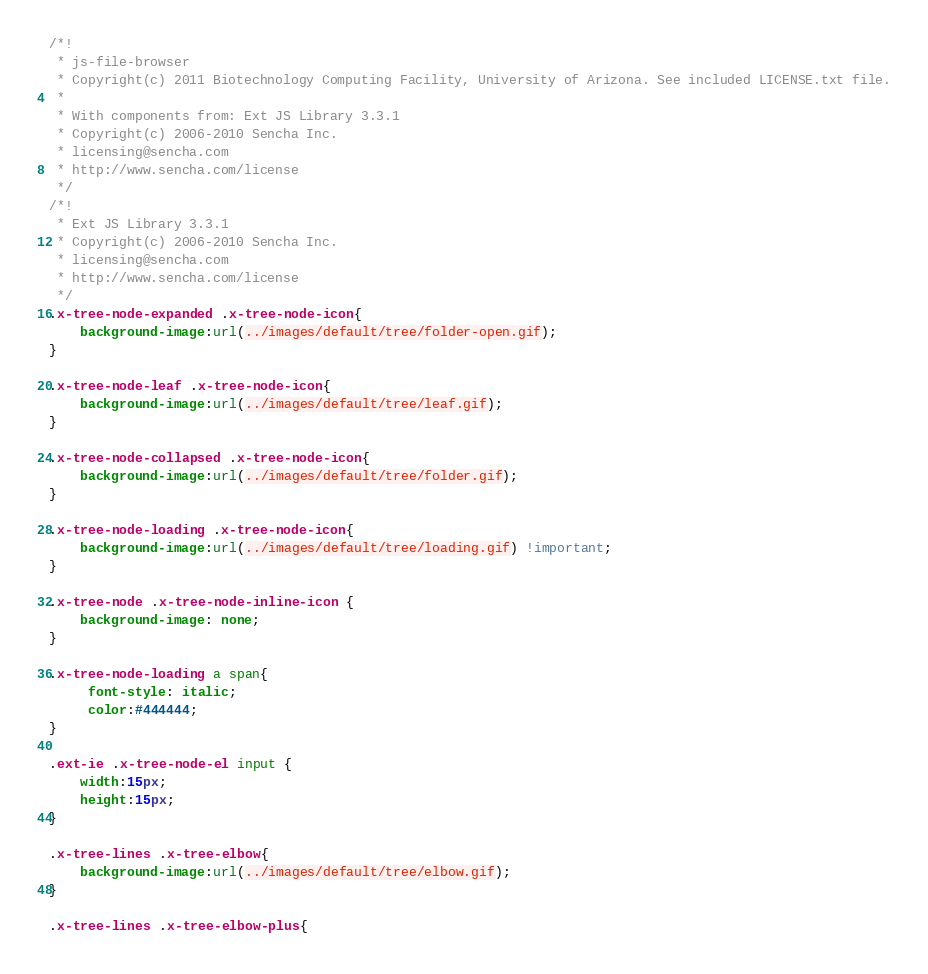Convert code to text. <code><loc_0><loc_0><loc_500><loc_500><_CSS_>/*!
 * js-file-browser
 * Copyright(c) 2011 Biotechnology Computing Facility, University of Arizona. See included LICENSE.txt file.
 * 
 * With components from: Ext JS Library 3.3.1
 * Copyright(c) 2006-2010 Sencha Inc.
 * licensing@sencha.com
 * http://www.sencha.com/license
 */
/*!
 * Ext JS Library 3.3.1
 * Copyright(c) 2006-2010 Sencha Inc.
 * licensing@sencha.com
 * http://www.sencha.com/license
 */
.x-tree-node-expanded .x-tree-node-icon{
	background-image:url(../images/default/tree/folder-open.gif);
}

.x-tree-node-leaf .x-tree-node-icon{
	background-image:url(../images/default/tree/leaf.gif);
}

.x-tree-node-collapsed .x-tree-node-icon{
	background-image:url(../images/default/tree/folder.gif);
}

.x-tree-node-loading .x-tree-node-icon{
	background-image:url(../images/default/tree/loading.gif) !important;
}

.x-tree-node .x-tree-node-inline-icon {
    background-image: none;
}

.x-tree-node-loading a span{
	 font-style: italic;
	 color:#444444;
}

.ext-ie .x-tree-node-el input {
    width:15px;
    height:15px;
}

.x-tree-lines .x-tree-elbow{
	background-image:url(../images/default/tree/elbow.gif);
}

.x-tree-lines .x-tree-elbow-plus{</code> 